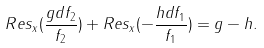<formula> <loc_0><loc_0><loc_500><loc_500>R e s _ { x } ( \frac { g d f _ { 2 } } { f _ { 2 } } ) + R e s _ { x } ( - \frac { h d f _ { 1 } } { f _ { 1 } } ) = g - h .</formula> 